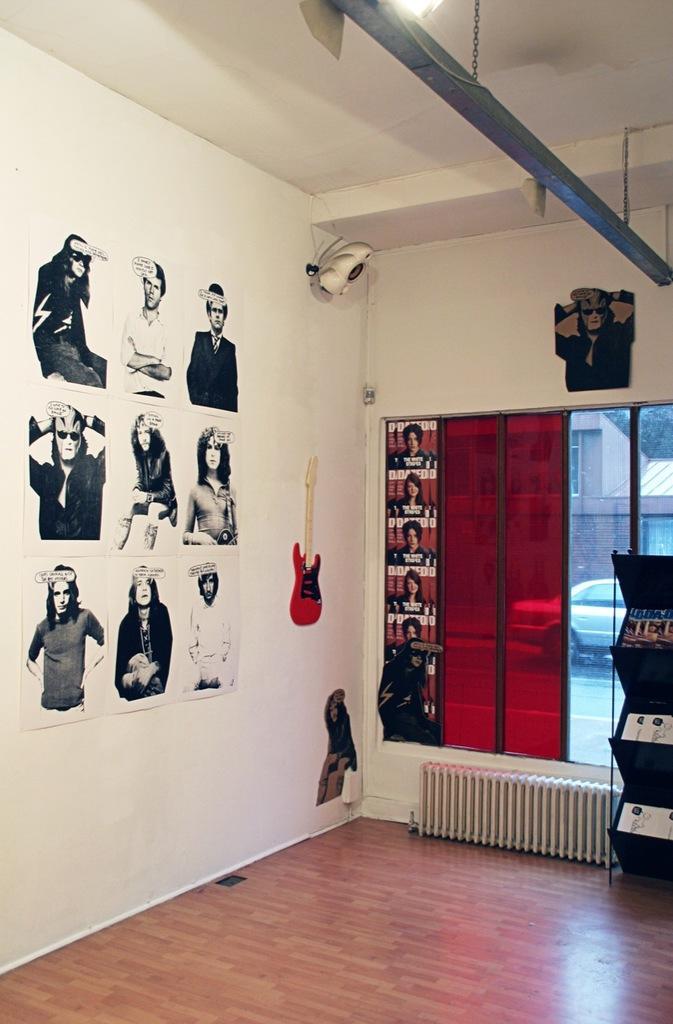Can you describe this image briefly? This is a picture of a room, we can see some posters on the wall, on the top of the roof, we can see a light and a pole, there is a glass door, through the glass door we can see a vehicle. 